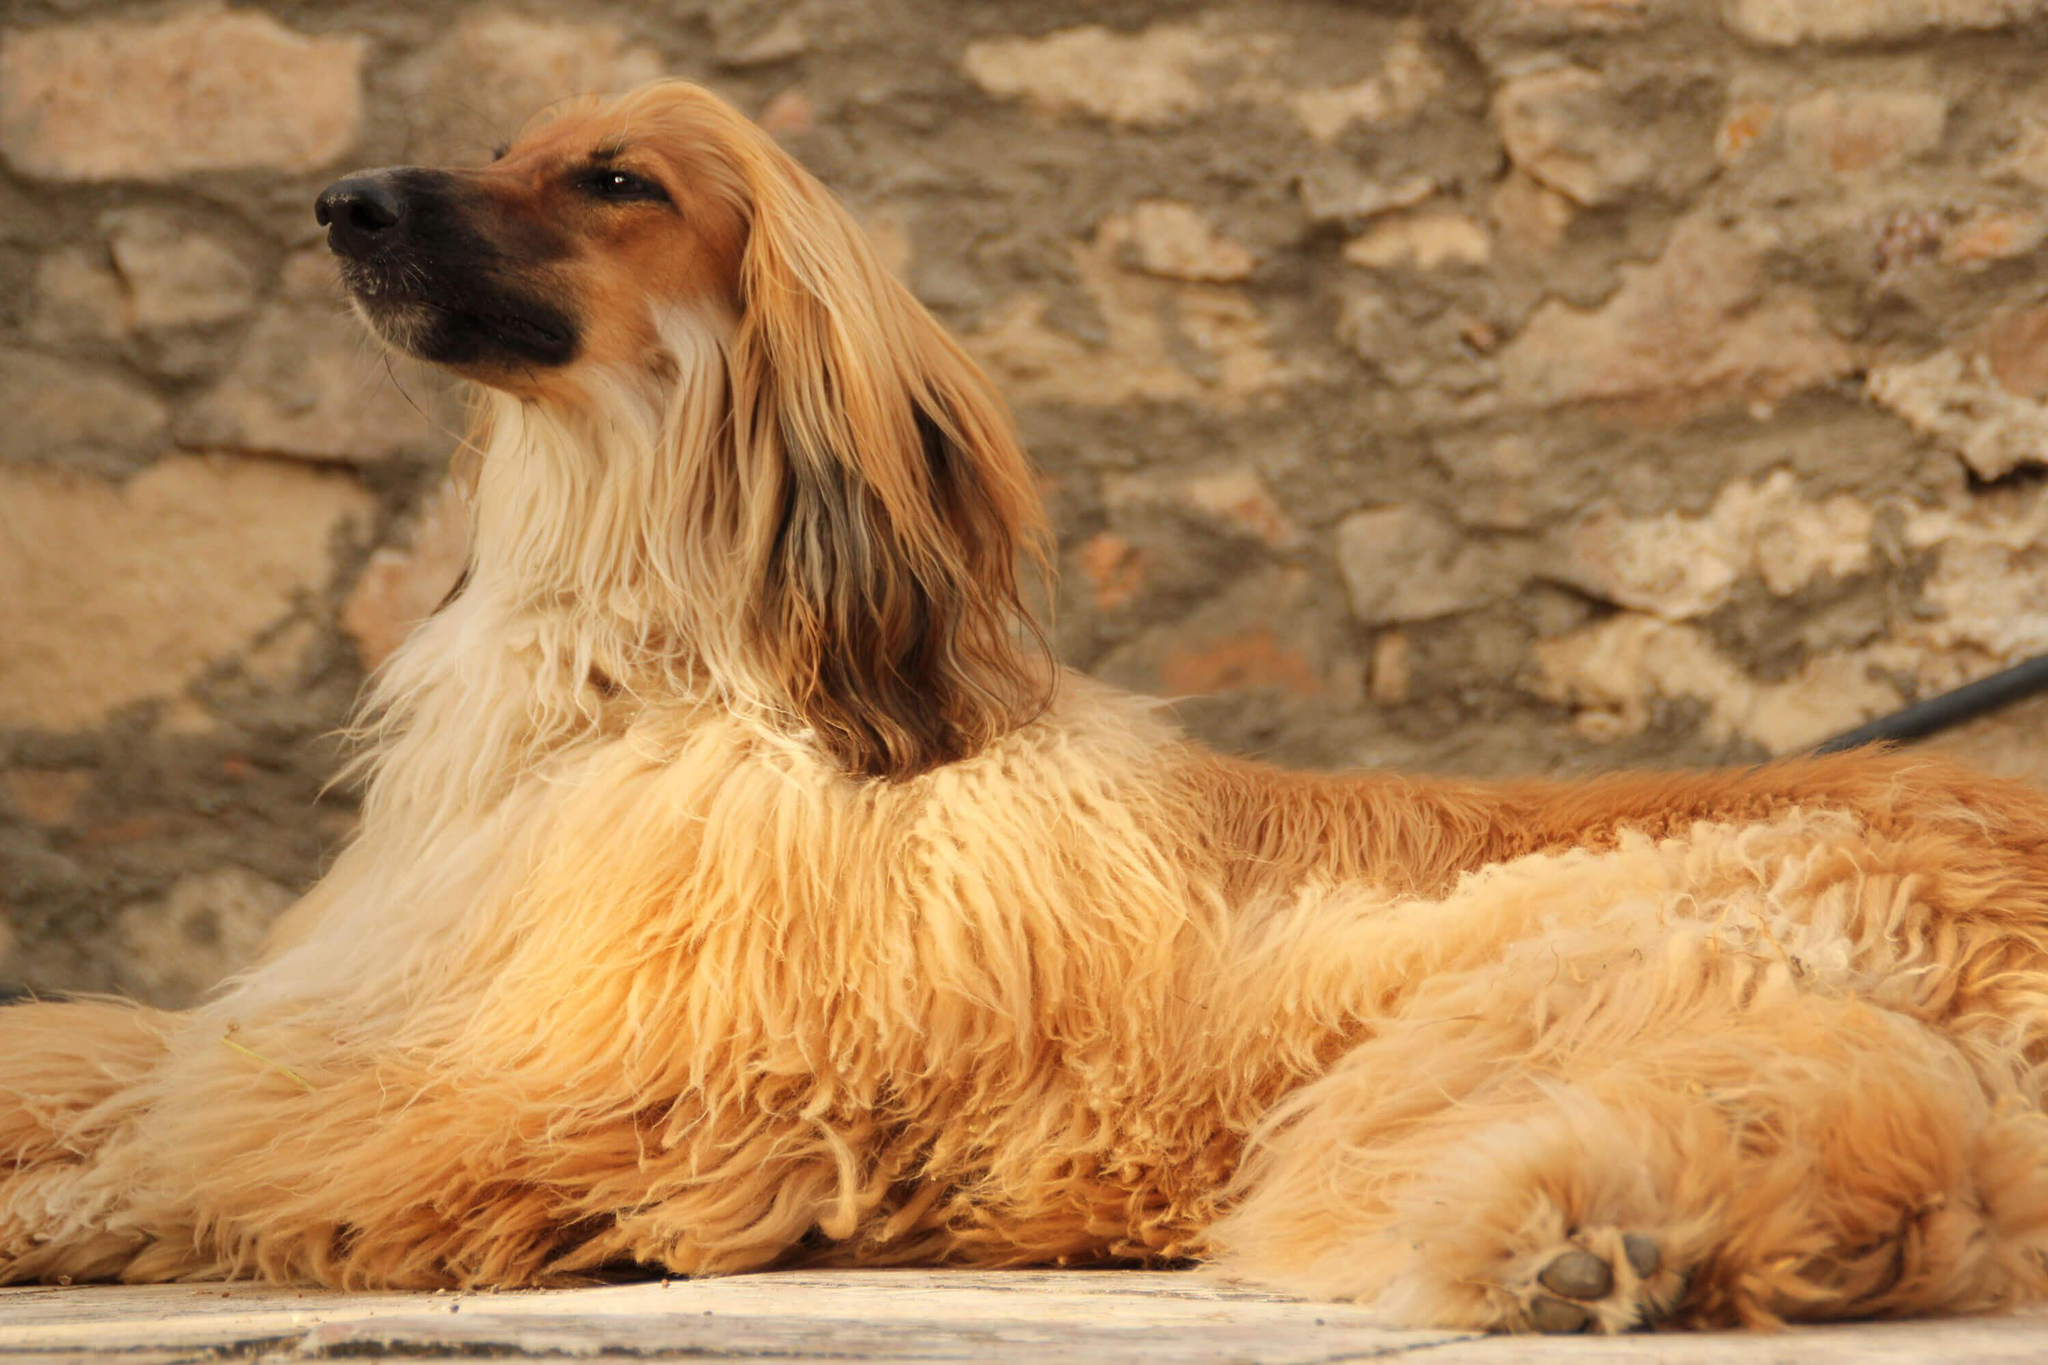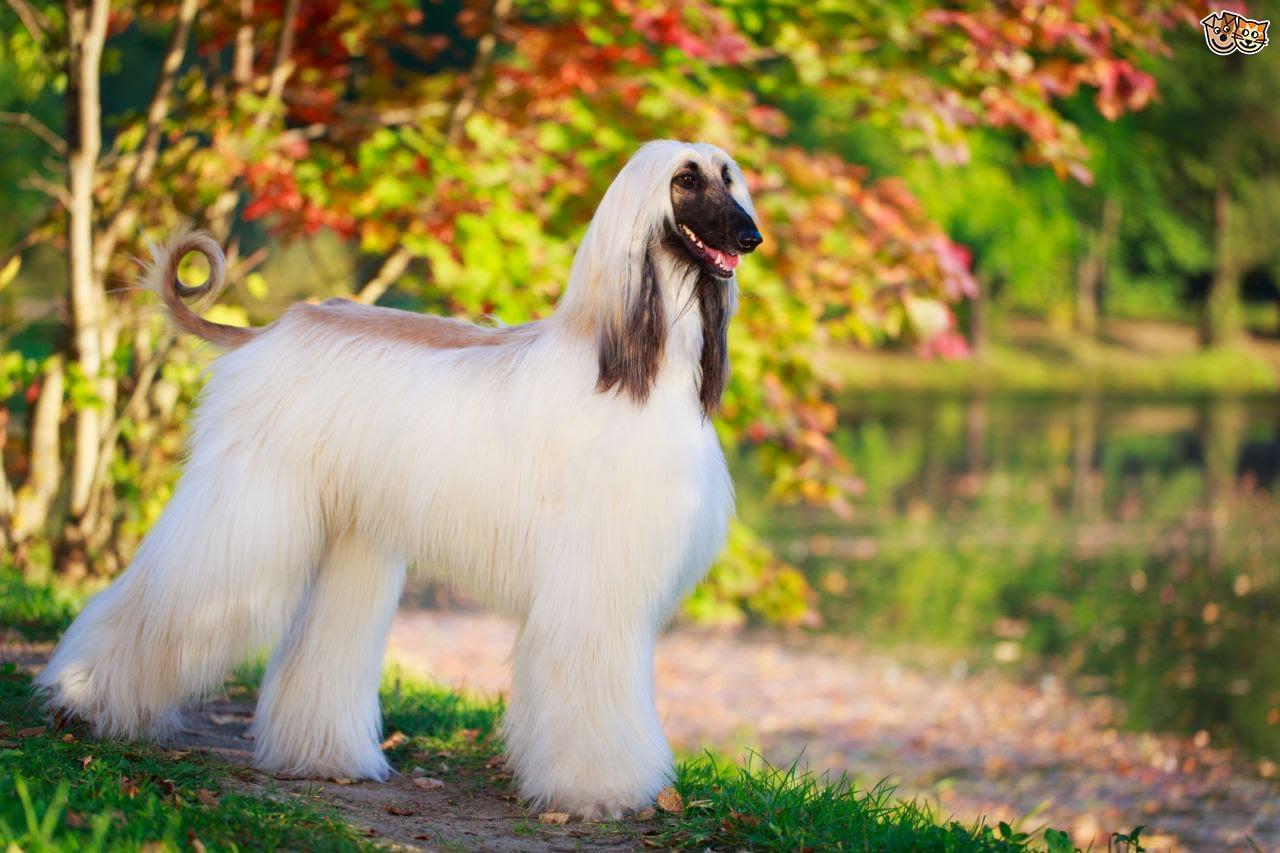The first image is the image on the left, the second image is the image on the right. For the images displayed, is the sentence "There are exactly three dogs in total." factually correct? Answer yes or no. No. The first image is the image on the left, the second image is the image on the right. Given the left and right images, does the statement "One photo contains exactly two dogs while the other photo contains only one, and all dogs are photographed outside in grass." hold true? Answer yes or no. No. 